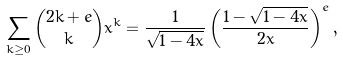Convert formula to latex. <formula><loc_0><loc_0><loc_500><loc_500>\sum _ { k \geq 0 } \binom { 2 k + e } { k } x ^ { k } = \frac { 1 } { \sqrt { 1 - 4 x } } \left ( \frac { 1 - \sqrt { 1 - 4 x } } { 2 x } \right ) ^ { e } ,</formula> 